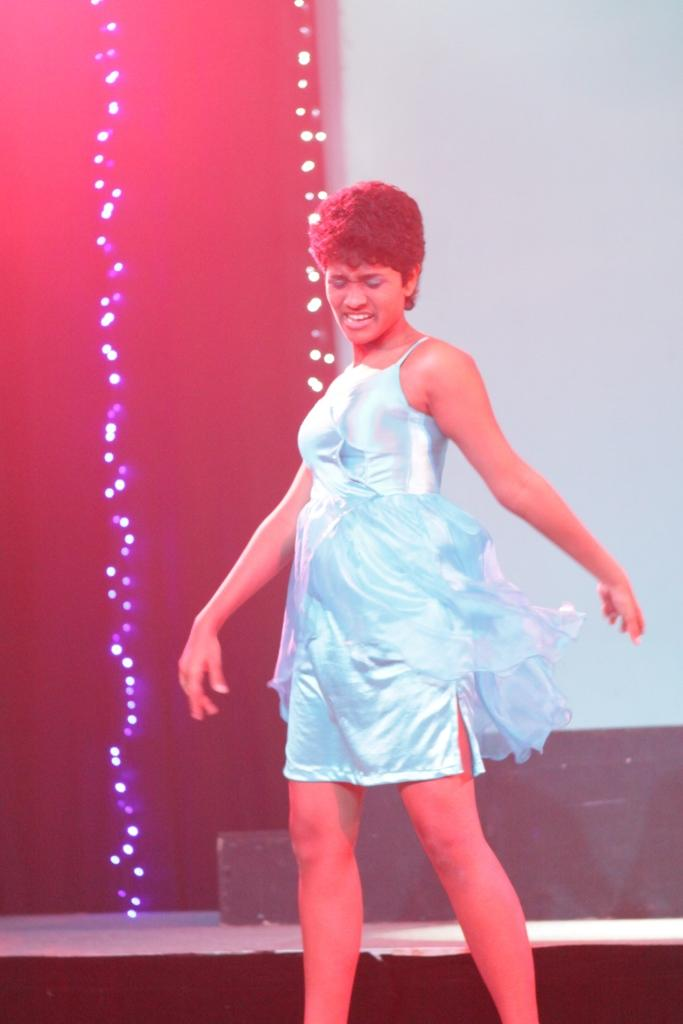Who is the main subject in the image? There is a woman in the image. What is the woman doing in the image? The woman is standing and appears to be dancing. Where is the woman located in the image? The woman is on a stage. What can be seen in the background of the image? There are lights visible in the background of the image. Can you tell me what book the woman is holding in the image? There is no book visible in the image; the woman is dancing on a stage. 